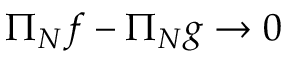Convert formula to latex. <formula><loc_0><loc_0><loc_500><loc_500>\Pi _ { N } f - \Pi _ { N } g \to 0</formula> 